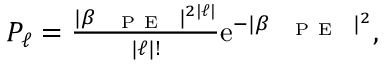Convert formula to latex. <formula><loc_0><loc_0><loc_500><loc_500>\begin{array} { r } { P _ { \ell } = \frac { | \beta _ { { P E } } | ^ { 2 | \ell | } } { | \ell | ! } e ^ { - | \beta _ { { P E } } | ^ { 2 } } , } \end{array}</formula> 